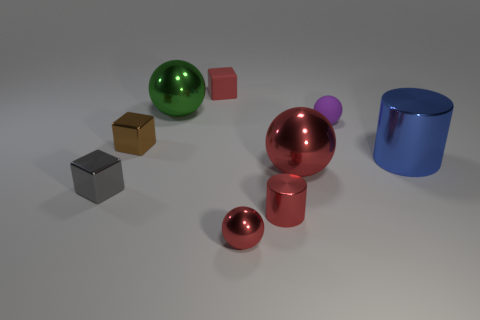There is a shiny cylinder that is the same color as the small matte cube; what is its size?
Your answer should be very brief. Small. There is a rubber thing that is in front of the cube that is behind the large green thing; what number of large red metallic spheres are behind it?
Offer a very short reply. 0. There is a cylinder that is right of the purple thing; what is its color?
Make the answer very short. Blue. There is a large shiny sphere to the right of the small red matte thing; is its color the same as the small shiny sphere?
Your response must be concise. Yes. What is the size of the green metal thing that is the same shape as the big red thing?
Provide a short and direct response. Large. There is a small sphere that is behind the red object in front of the small red shiny object on the right side of the tiny red metallic ball; what is it made of?
Provide a short and direct response. Rubber. Is the number of tiny things in front of the small brown block greater than the number of brown things that are behind the red cylinder?
Offer a very short reply. Yes. Does the purple thing have the same size as the gray metallic block?
Provide a short and direct response. Yes. There is another small metallic thing that is the same shape as the green object; what is its color?
Your response must be concise. Red. What number of big metallic balls have the same color as the small metallic cylinder?
Make the answer very short. 1. 